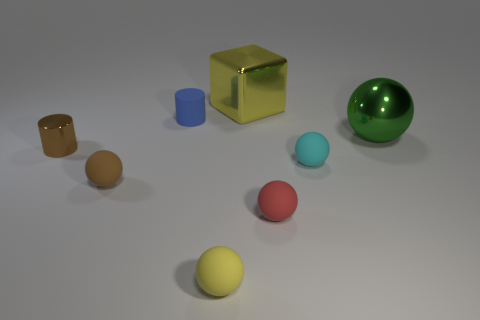There is a matte object that is behind the big metal object right of the small cyan thing; what color is it?
Your response must be concise. Blue. What number of other things are made of the same material as the small cyan sphere?
Give a very brief answer. 4. Is the number of yellow rubber objects that are left of the tiny blue thing the same as the number of big green metal cubes?
Make the answer very short. Yes. There is a object that is to the left of the rubber ball on the left side of the small sphere in front of the small red rubber object; what is its material?
Provide a short and direct response. Metal. What is the color of the big shiny object that is in front of the small blue cylinder?
Provide a short and direct response. Green. Are there any other things that have the same shape as the yellow matte thing?
Offer a terse response. Yes. There is a cyan ball that is left of the big shiny object right of the large yellow thing; what is its size?
Your answer should be very brief. Small. Are there an equal number of yellow blocks that are in front of the blue cylinder and small red things on the left side of the metallic cube?
Make the answer very short. Yes. Are there any other things that are the same size as the yellow matte sphere?
Provide a succinct answer. Yes. The small cylinder that is made of the same material as the cyan sphere is what color?
Give a very brief answer. Blue. 